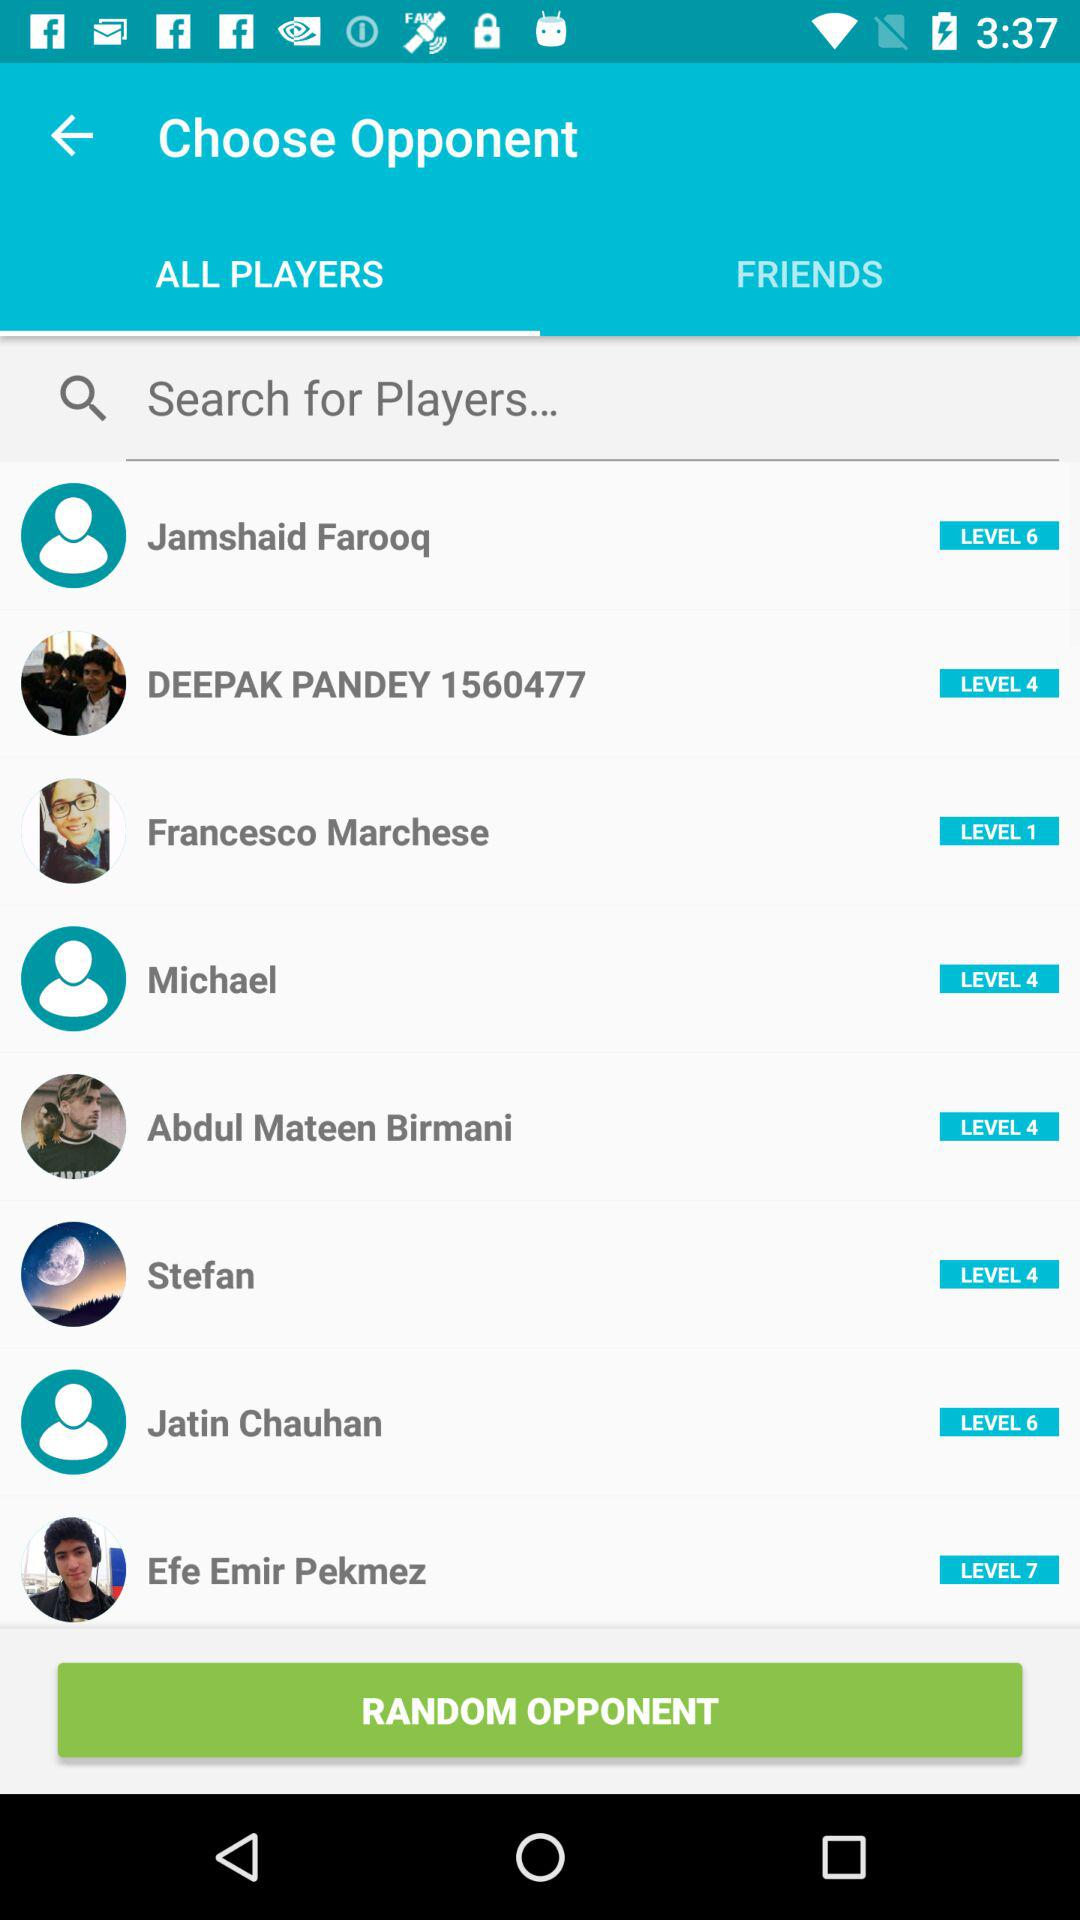What is the level of Stefan? The level of Stefan is 4. 